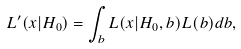Convert formula to latex. <formula><loc_0><loc_0><loc_500><loc_500>L ^ { \prime } ( x | H _ { 0 } ) = \int _ { b } L ( x | H _ { 0 } , b ) L ( b ) d b ,</formula> 